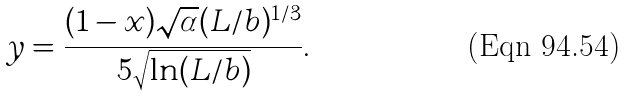<formula> <loc_0><loc_0><loc_500><loc_500>y = \frac { ( 1 - x ) \sqrt { \alpha } ( L / b ) ^ { 1 / 3 } } { 5 \sqrt { \ln ( L / b ) } } .</formula> 